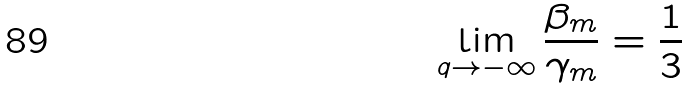<formula> <loc_0><loc_0><loc_500><loc_500>\lim _ { q \rightarrow - \infty } \frac { \beta _ { m } } { \gamma _ { m } } = \frac { 1 } { 3 }</formula> 